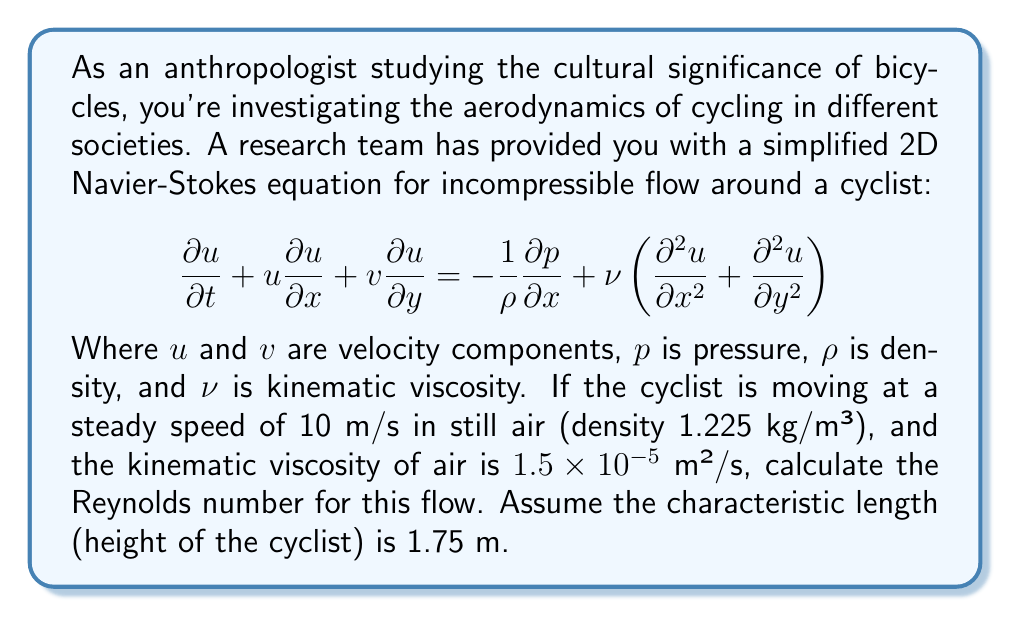Help me with this question. To solve this problem, we need to understand the concept of Reynolds number and how it relates to the Navier-Stokes equations. The Reynolds number is a dimensionless quantity that helps predict flow patterns in different fluid flow situations. It's defined as:

$$Re = \frac{UL}{\nu}$$

Where:
$Re$ is the Reynolds number
$U$ is the characteristic velocity (in this case, the cyclist's speed)
$L$ is the characteristic length (in this case, the height of the cyclist)
$\nu$ is the kinematic viscosity of the fluid (air)

Given:
- Cyclist's speed (U) = 10 m/s
- Cyclist's height (L) = 1.75 m
- Kinematic viscosity of air (ν) = $1.5 \times 10^{-5}$ m²/s

Now, let's substitute these values into the Reynolds number equation:

$$Re = \frac{(10 \text{ m/s})(1.75 \text{ m})}{1.5 \times 10^{-5} \text{ m²/s}}$$

$$Re = \frac{17.5}{1.5 \times 10^{-5}}$$

$$Re = 1,166,666.67$$

Typically, we round the Reynolds number to three significant figures, so our final answer would be $1.17 \times 10^6$.

This high Reynolds number indicates that the flow around the cyclist is likely to be turbulent, which is important for understanding the aerodynamics and energy efficiency of cycling in different cultural contexts.
Answer: $1.17 \times 10^6$ 